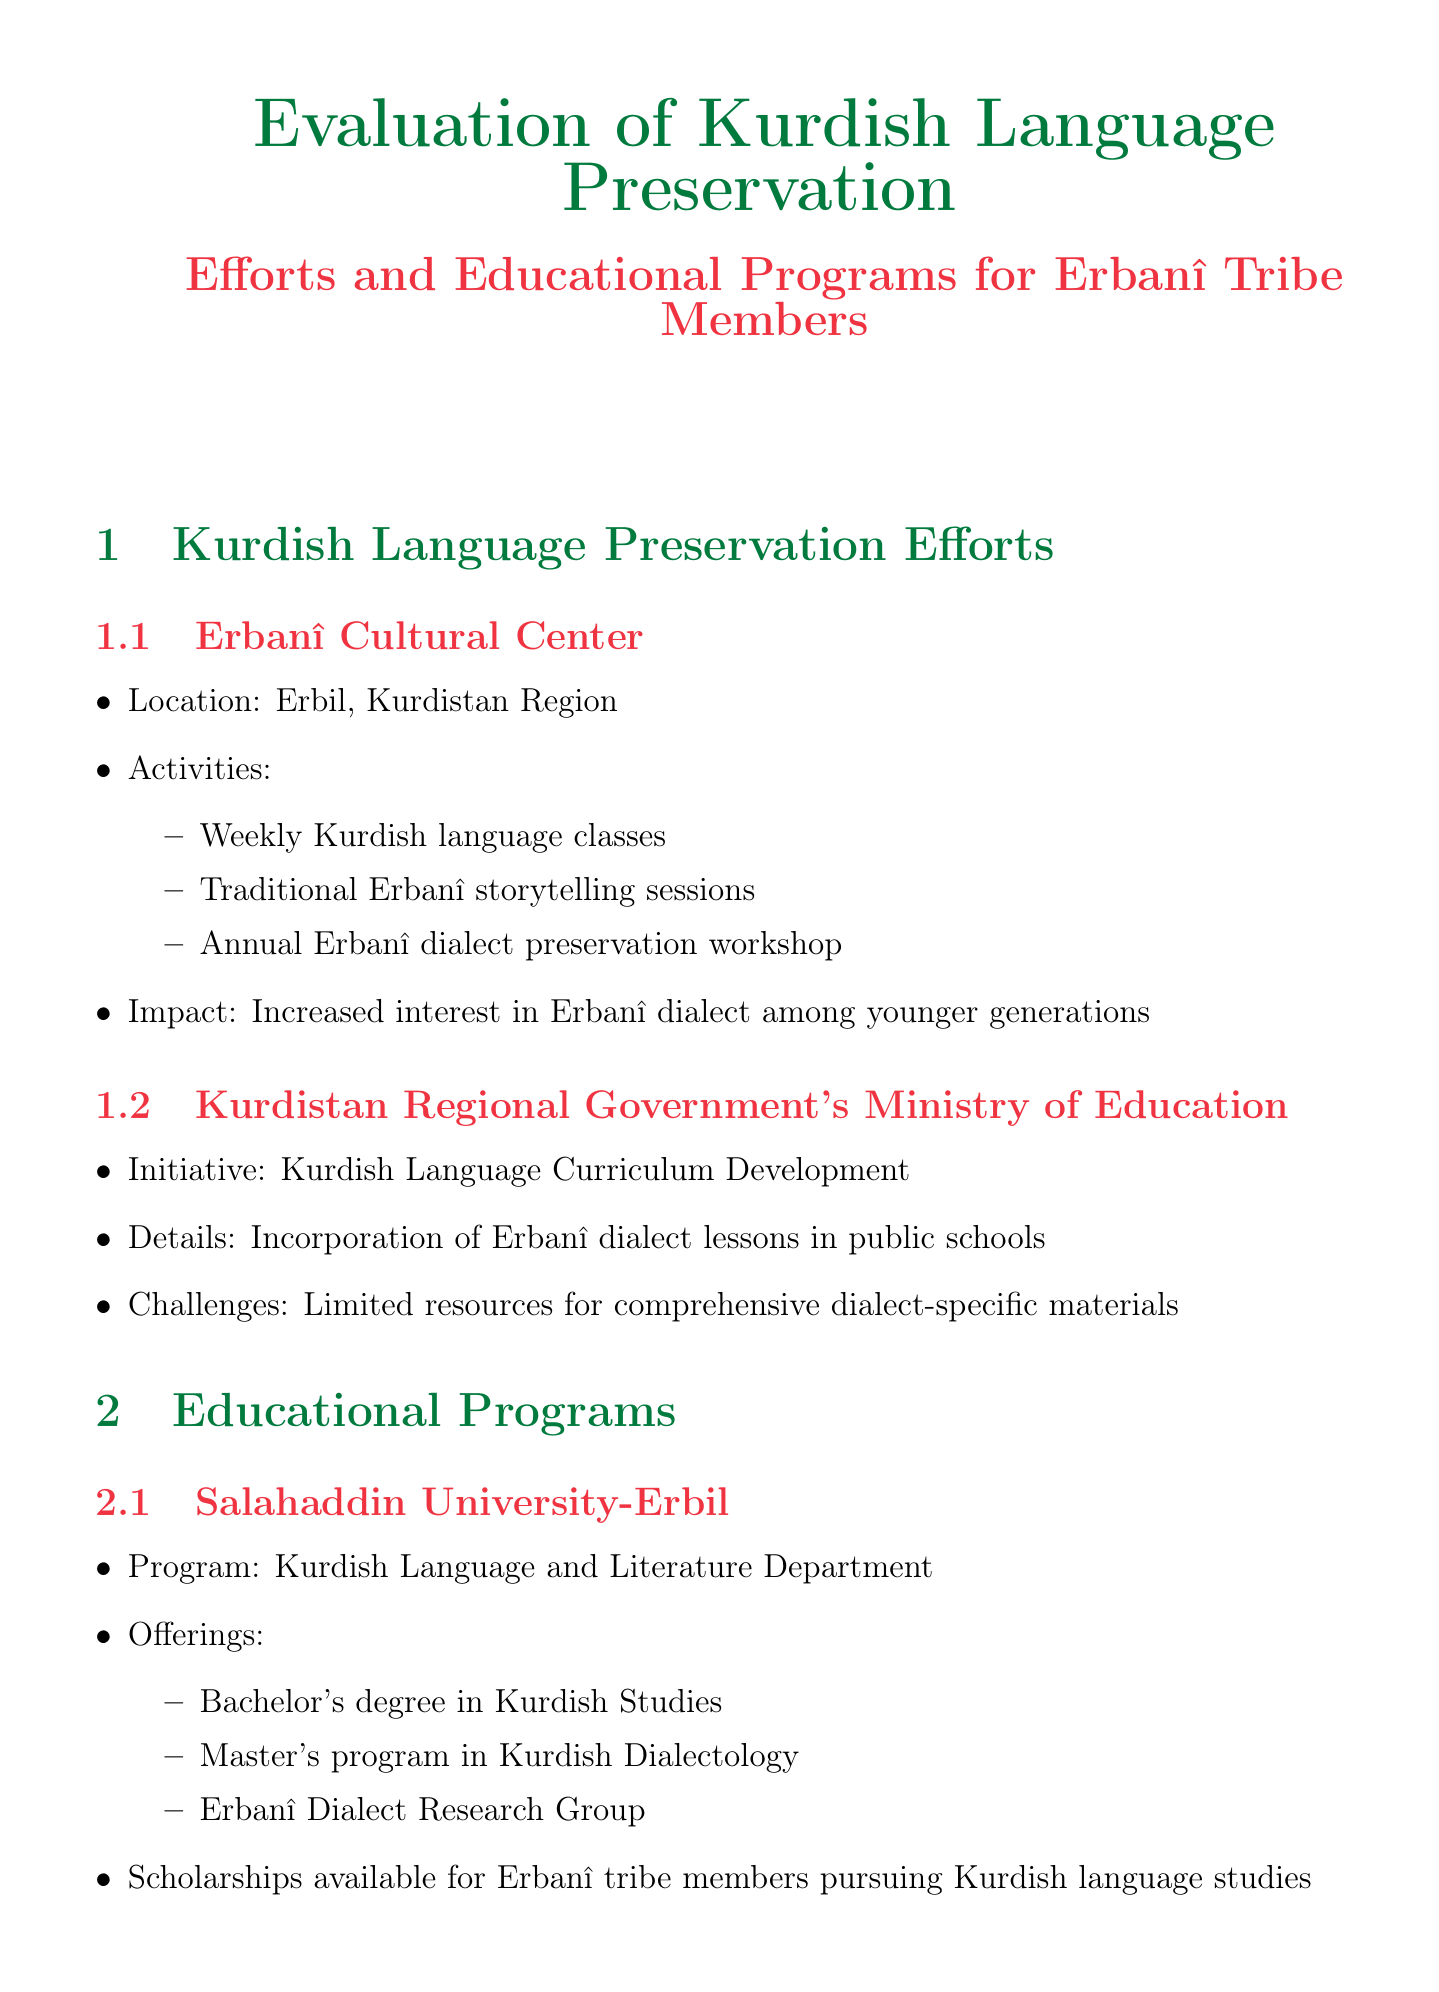What is the location of the Erbanî Cultural Center? The Erbanî Cultural Center is located in Erbil, Kurdistan Region.
Answer: Erbil, Kurdistan Region What activities are offered by the Kurdistan Regional Government's Ministry of Education? The initiative incorporates Erbanî dialect lessons in public schools.
Answer: Incorporation of Erbanî dialect lessons in public schools How many offerings does Salahaddin University-Erbil provide in the Kurdish Language and Literature Department? The document states that it offers a bachelor's degree, a master's program, and an Erbanî research group, totaling three offerings.
Answer: Three offerings What is the project undertaken by the Erbanî Elders Council? The project focuses on documenting oral history in the native dialect.
Answer: Oral History Documentation What is a proposed solution for the issue of urban assimilation? The solution proposed is the creation of Erbanî-only zones in community centers.
Answer: Creation of Erbanî-only zones in community centers How many participants are involved in the Oral History Documentation project? The document mentions 50 Erbanî elders are participating.
Answer: 50 What type of technology is used in the Erbanî Digital Archive Project? The project is based on a mobile app and website platform.
Answer: Mobile app and website What university collaborates on the Erbanî Dialect Documentation project? The document specifies the University of Toronto as the partner for this project.
Answer: University of Toronto What can users find in the Erbanî Digital Archive Project's features? Users can find an Erbanî-Kurdish-English dictionary among other features.
Answer: Erbanî-Kurdish-English dictionary 